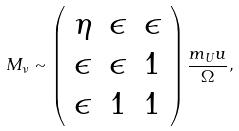Convert formula to latex. <formula><loc_0><loc_0><loc_500><loc_500>M _ { \nu } \sim \left ( \begin{array} { c c c } \eta & \epsilon & \epsilon \\ \epsilon & \epsilon & 1 \\ \epsilon & 1 & 1 \end{array} \right ) \frac { m _ { U } u } { \Omega } ,</formula> 